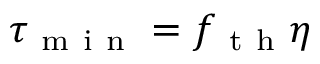<formula> <loc_0><loc_0><loc_500><loc_500>\tau _ { m i n } = f _ { t h } \eta</formula> 